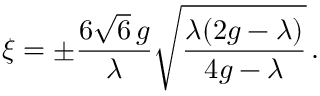<formula> <loc_0><loc_0><loc_500><loc_500>\xi = \pm \frac { 6 \sqrt { 6 } \, g } { \lambda } \sqrt { \frac { \lambda ( 2 g - \lambda ) } { 4 g - \lambda } } \, .</formula> 